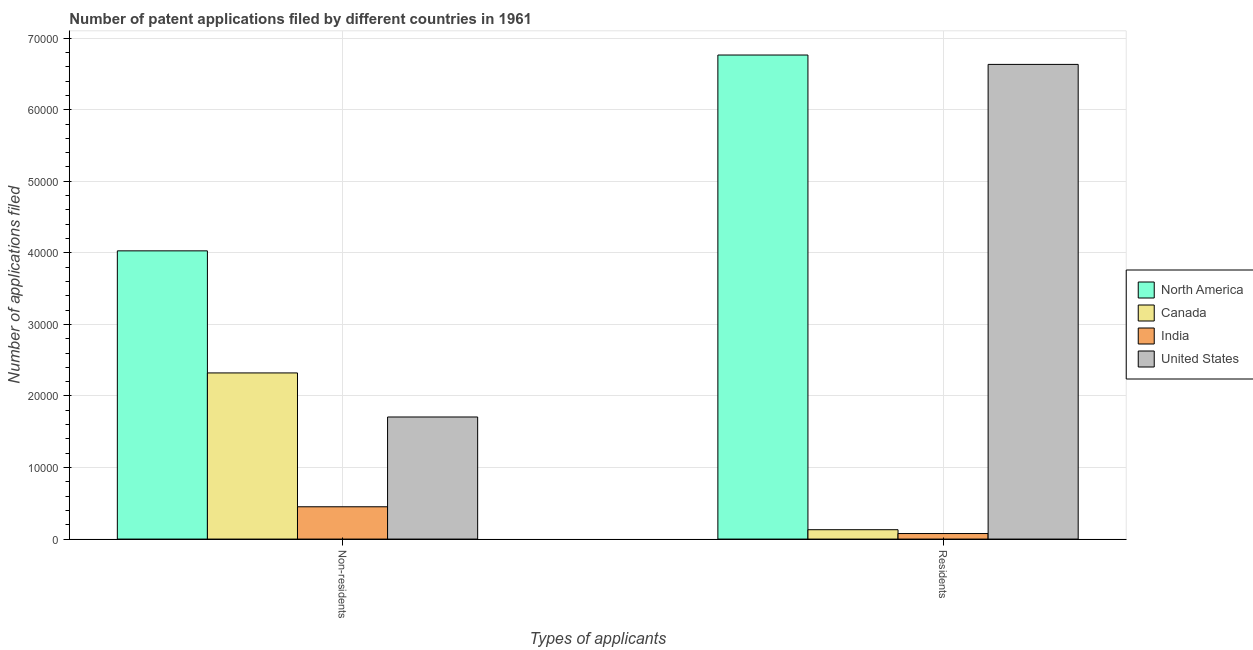How many groups of bars are there?
Your answer should be compact. 2. Are the number of bars per tick equal to the number of legend labels?
Provide a succinct answer. Yes. Are the number of bars on each tick of the X-axis equal?
Offer a very short reply. Yes. How many bars are there on the 1st tick from the right?
Your answer should be very brief. 4. What is the label of the 1st group of bars from the left?
Your answer should be compact. Non-residents. What is the number of patent applications by non residents in United States?
Keep it short and to the point. 1.71e+04. Across all countries, what is the maximum number of patent applications by non residents?
Your response must be concise. 4.03e+04. Across all countries, what is the minimum number of patent applications by non residents?
Make the answer very short. 4515. In which country was the number of patent applications by non residents maximum?
Make the answer very short. North America. What is the total number of patent applications by residents in the graph?
Provide a short and direct response. 1.36e+05. What is the difference between the number of patent applications by non residents in United States and that in North America?
Offer a very short reply. -2.32e+04. What is the difference between the number of patent applications by residents in India and the number of patent applications by non residents in North America?
Ensure brevity in your answer.  -3.95e+04. What is the average number of patent applications by non residents per country?
Your response must be concise. 2.13e+04. What is the difference between the number of patent applications by non residents and number of patent applications by residents in Canada?
Provide a short and direct response. 2.19e+04. What is the ratio of the number of patent applications by non residents in India to that in North America?
Provide a succinct answer. 0.11. In how many countries, is the number of patent applications by residents greater than the average number of patent applications by residents taken over all countries?
Provide a succinct answer. 2. What does the 2nd bar from the left in Non-residents represents?
Keep it short and to the point. Canada. What does the 3rd bar from the right in Non-residents represents?
Make the answer very short. Canada. How many countries are there in the graph?
Give a very brief answer. 4. What is the difference between two consecutive major ticks on the Y-axis?
Your answer should be very brief. 10000. Does the graph contain any zero values?
Provide a short and direct response. No. Does the graph contain grids?
Offer a very short reply. Yes. Where does the legend appear in the graph?
Offer a terse response. Center right. How many legend labels are there?
Offer a terse response. 4. How are the legend labels stacked?
Provide a succinct answer. Vertical. What is the title of the graph?
Your answer should be compact. Number of patent applications filed by different countries in 1961. Does "Swaziland" appear as one of the legend labels in the graph?
Offer a terse response. No. What is the label or title of the X-axis?
Provide a short and direct response. Types of applicants. What is the label or title of the Y-axis?
Make the answer very short. Number of applications filed. What is the Number of applications filed of North America in Non-residents?
Offer a very short reply. 4.03e+04. What is the Number of applications filed in Canada in Non-residents?
Give a very brief answer. 2.32e+04. What is the Number of applications filed in India in Non-residents?
Keep it short and to the point. 4515. What is the Number of applications filed of United States in Non-residents?
Your response must be concise. 1.71e+04. What is the Number of applications filed of North America in Residents?
Your response must be concise. 6.76e+04. What is the Number of applications filed of Canada in Residents?
Your answer should be compact. 1310. What is the Number of applications filed of India in Residents?
Your answer should be compact. 774. What is the Number of applications filed of United States in Residents?
Provide a short and direct response. 6.63e+04. Across all Types of applicants, what is the maximum Number of applications filed in North America?
Keep it short and to the point. 6.76e+04. Across all Types of applicants, what is the maximum Number of applications filed of Canada?
Your answer should be compact. 2.32e+04. Across all Types of applicants, what is the maximum Number of applications filed of India?
Ensure brevity in your answer.  4515. Across all Types of applicants, what is the maximum Number of applications filed in United States?
Provide a succinct answer. 6.63e+04. Across all Types of applicants, what is the minimum Number of applications filed in North America?
Offer a terse response. 4.03e+04. Across all Types of applicants, what is the minimum Number of applications filed in Canada?
Offer a very short reply. 1310. Across all Types of applicants, what is the minimum Number of applications filed of India?
Your response must be concise. 774. Across all Types of applicants, what is the minimum Number of applications filed in United States?
Keep it short and to the point. 1.71e+04. What is the total Number of applications filed in North America in the graph?
Your answer should be compact. 1.08e+05. What is the total Number of applications filed of Canada in the graph?
Make the answer very short. 2.45e+04. What is the total Number of applications filed in India in the graph?
Your response must be concise. 5289. What is the total Number of applications filed in United States in the graph?
Make the answer very short. 8.34e+04. What is the difference between the Number of applications filed in North America in Non-residents and that in Residents?
Your answer should be compact. -2.74e+04. What is the difference between the Number of applications filed in Canada in Non-residents and that in Residents?
Provide a short and direct response. 2.19e+04. What is the difference between the Number of applications filed in India in Non-residents and that in Residents?
Ensure brevity in your answer.  3741. What is the difference between the Number of applications filed in United States in Non-residents and that in Residents?
Provide a short and direct response. -4.93e+04. What is the difference between the Number of applications filed in North America in Non-residents and the Number of applications filed in Canada in Residents?
Your answer should be compact. 3.90e+04. What is the difference between the Number of applications filed in North America in Non-residents and the Number of applications filed in India in Residents?
Your answer should be compact. 3.95e+04. What is the difference between the Number of applications filed of North America in Non-residents and the Number of applications filed of United States in Residents?
Provide a short and direct response. -2.61e+04. What is the difference between the Number of applications filed of Canada in Non-residents and the Number of applications filed of India in Residents?
Give a very brief answer. 2.24e+04. What is the difference between the Number of applications filed in Canada in Non-residents and the Number of applications filed in United States in Residents?
Make the answer very short. -4.31e+04. What is the difference between the Number of applications filed of India in Non-residents and the Number of applications filed of United States in Residents?
Provide a succinct answer. -6.18e+04. What is the average Number of applications filed of North America per Types of applicants?
Keep it short and to the point. 5.40e+04. What is the average Number of applications filed in Canada per Types of applicants?
Ensure brevity in your answer.  1.23e+04. What is the average Number of applications filed in India per Types of applicants?
Your answer should be compact. 2644.5. What is the average Number of applications filed in United States per Types of applicants?
Give a very brief answer. 4.17e+04. What is the difference between the Number of applications filed of North America and Number of applications filed of Canada in Non-residents?
Provide a short and direct response. 1.71e+04. What is the difference between the Number of applications filed in North America and Number of applications filed in India in Non-residents?
Make the answer very short. 3.58e+04. What is the difference between the Number of applications filed in North America and Number of applications filed in United States in Non-residents?
Ensure brevity in your answer.  2.32e+04. What is the difference between the Number of applications filed in Canada and Number of applications filed in India in Non-residents?
Give a very brief answer. 1.87e+04. What is the difference between the Number of applications filed of Canada and Number of applications filed of United States in Non-residents?
Ensure brevity in your answer.  6158. What is the difference between the Number of applications filed of India and Number of applications filed of United States in Non-residents?
Offer a terse response. -1.25e+04. What is the difference between the Number of applications filed in North America and Number of applications filed in Canada in Residents?
Your answer should be compact. 6.63e+04. What is the difference between the Number of applications filed of North America and Number of applications filed of India in Residents?
Your answer should be compact. 6.69e+04. What is the difference between the Number of applications filed of North America and Number of applications filed of United States in Residents?
Provide a succinct answer. 1310. What is the difference between the Number of applications filed in Canada and Number of applications filed in India in Residents?
Keep it short and to the point. 536. What is the difference between the Number of applications filed in Canada and Number of applications filed in United States in Residents?
Provide a short and direct response. -6.50e+04. What is the difference between the Number of applications filed in India and Number of applications filed in United States in Residents?
Offer a very short reply. -6.56e+04. What is the ratio of the Number of applications filed in North America in Non-residents to that in Residents?
Provide a short and direct response. 0.6. What is the ratio of the Number of applications filed in Canada in Non-residents to that in Residents?
Make the answer very short. 17.72. What is the ratio of the Number of applications filed in India in Non-residents to that in Residents?
Keep it short and to the point. 5.83. What is the ratio of the Number of applications filed of United States in Non-residents to that in Residents?
Your answer should be compact. 0.26. What is the difference between the highest and the second highest Number of applications filed of North America?
Provide a short and direct response. 2.74e+04. What is the difference between the highest and the second highest Number of applications filed of Canada?
Your answer should be very brief. 2.19e+04. What is the difference between the highest and the second highest Number of applications filed of India?
Ensure brevity in your answer.  3741. What is the difference between the highest and the second highest Number of applications filed in United States?
Give a very brief answer. 4.93e+04. What is the difference between the highest and the lowest Number of applications filed in North America?
Offer a terse response. 2.74e+04. What is the difference between the highest and the lowest Number of applications filed of Canada?
Offer a very short reply. 2.19e+04. What is the difference between the highest and the lowest Number of applications filed of India?
Keep it short and to the point. 3741. What is the difference between the highest and the lowest Number of applications filed of United States?
Offer a very short reply. 4.93e+04. 